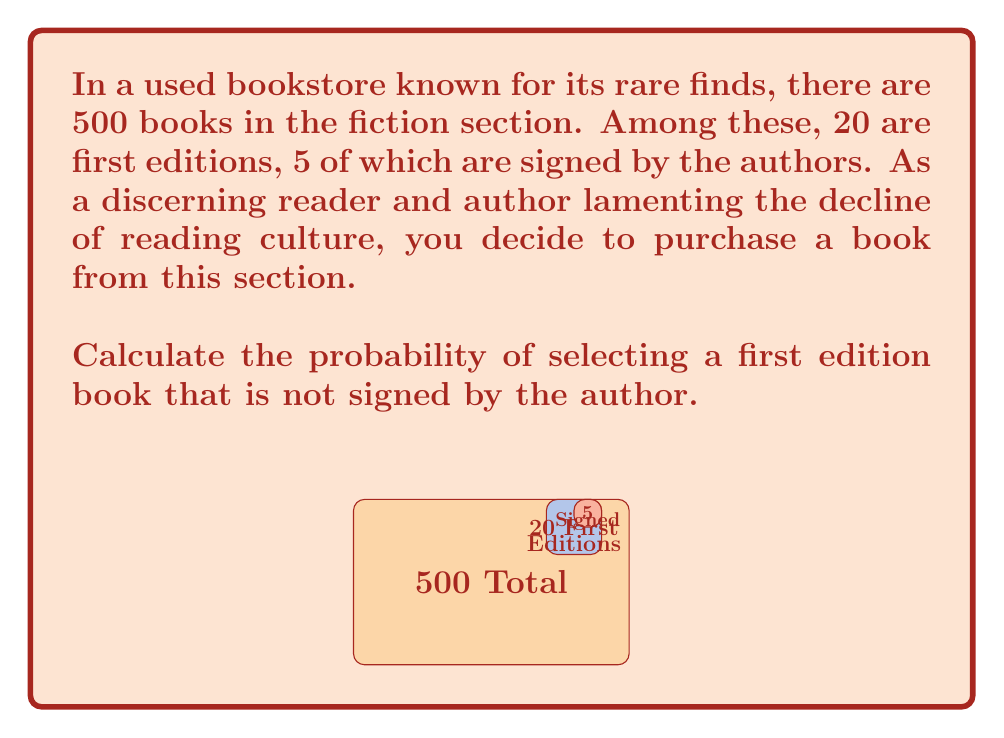Could you help me with this problem? Let's approach this step-by-step:

1) First, we need to identify the total number of favorable outcomes and the total number of possible outcomes.

2) Total number of possible outcomes:
   $$ \text{Total books} = 500 $$

3) Number of first edition books:
   $$ \text{First editions} = 20 $$

4) Number of signed first editions:
   $$ \text{Signed first editions} = 5 $$

5) Therefore, the number of unsigned first editions is:
   $$ \text{Unsigned first editions} = 20 - 5 = 15 $$

6) The probability of selecting an unsigned first edition is:
   $$ P(\text{Unsigned first edition}) = \frac{\text{Unsigned first editions}}{\text{Total books}} $$

7) Substituting the values:
   $$ P(\text{Unsigned first edition}) = \frac{15}{500} = \frac{3}{100} = 0.03 $$

Thus, the probability of selecting a first edition book that is not signed by the author is 0.03 or 3%.
Answer: $\frac{3}{100}$ or $0.03$ or $3\%$ 